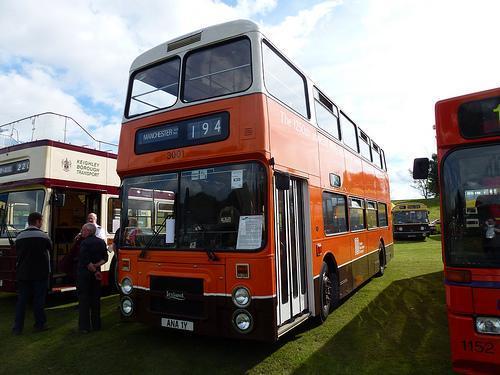How many buses are in the image?
Give a very brief answer. 4. How many people are in the image?
Give a very brief answer. 3. 